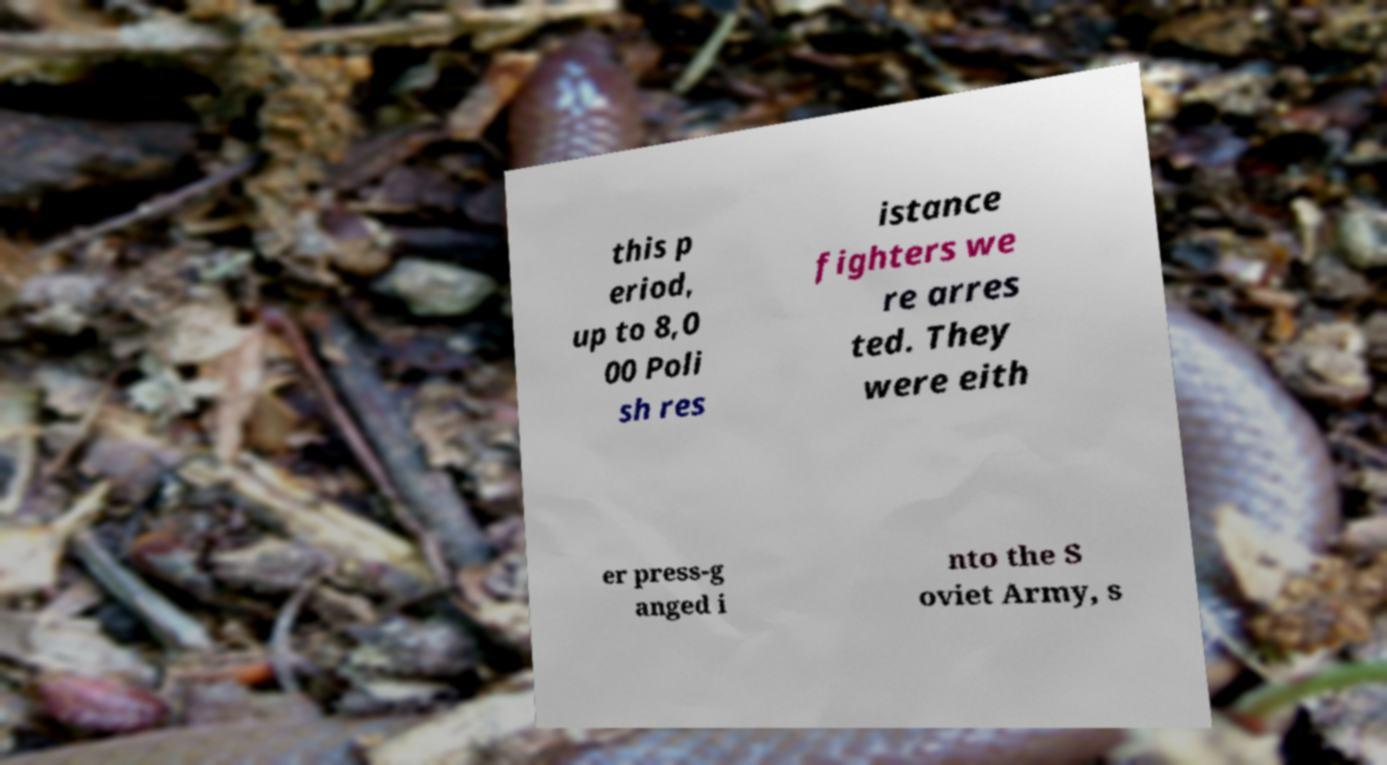Please identify and transcribe the text found in this image. this p eriod, up to 8,0 00 Poli sh res istance fighters we re arres ted. They were eith er press-g anged i nto the S oviet Army, s 